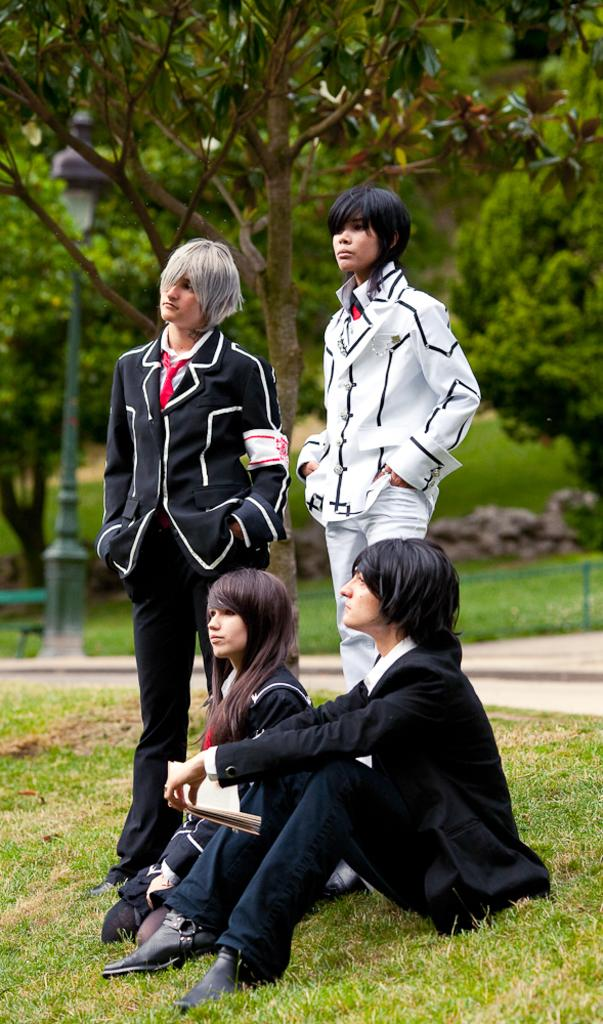What are the people in the image doing? The people in the image are sitting on the grass at the bottom and standing in the middle. What can be seen behind the standing persons? There are trees behind the standing persons. What other objects are visible in the image? There are poles visible in the image. What type of mailbox is located near the standing persons? There is no mailbox present in the image. What does the father of the standing persons look like? There is no father mentioned or visible in the image. 